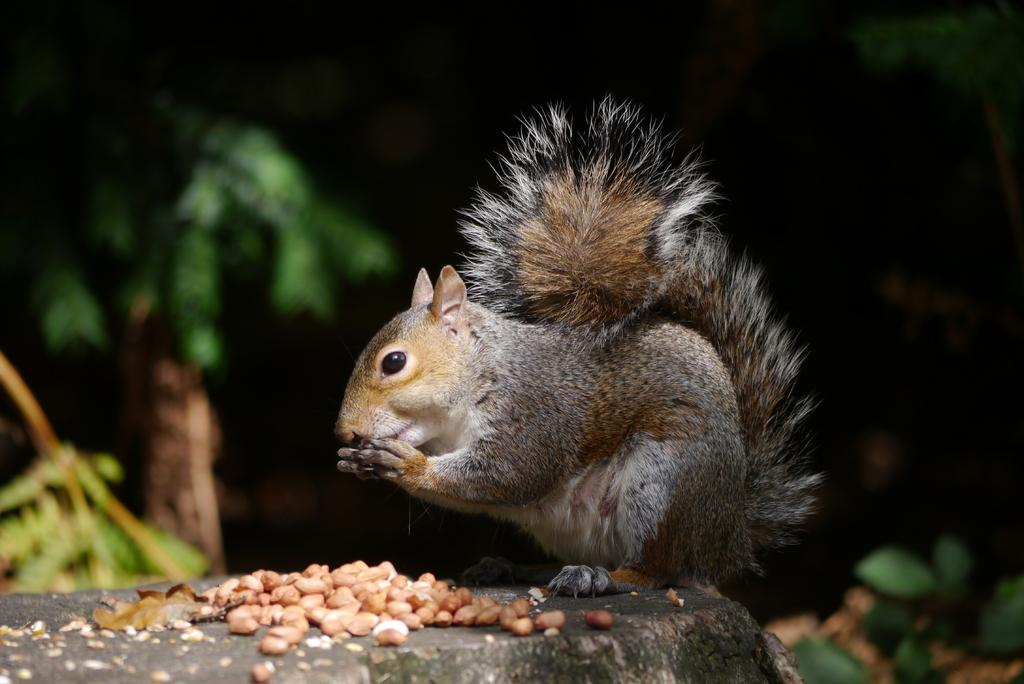What type of animal is in the image? There is a squirrel in the image. What is the squirrel interacting with in the image? The squirrel is interacting with nuts on the stone in the image. What can be seen in the background of the image? There are trees in the background of the image. Who is the father of the squirrel in the image? There is no indication of the squirrel's family in the image, so it is not possible to determine the father of the squirrel. 